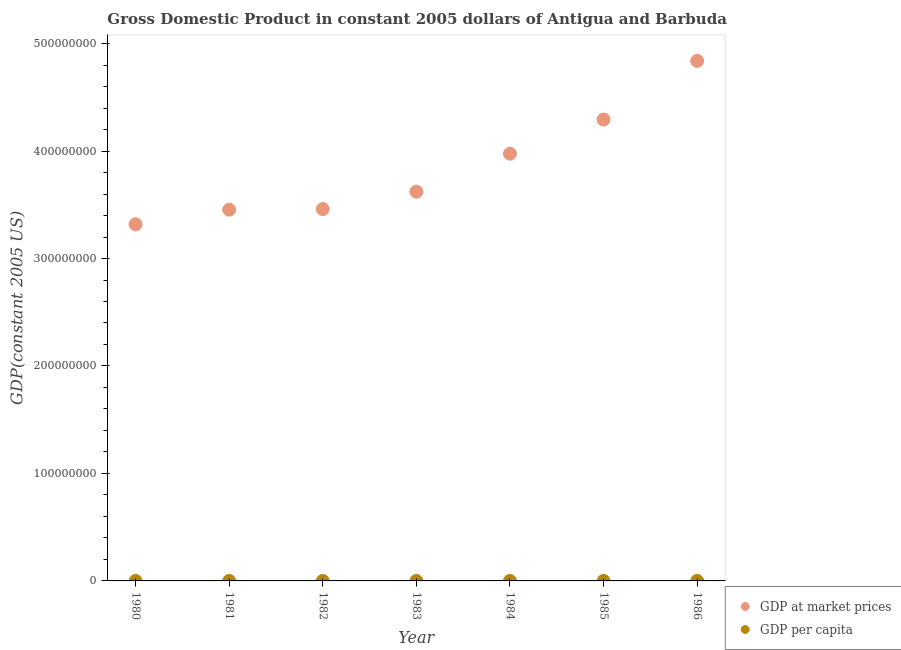How many different coloured dotlines are there?
Provide a short and direct response. 2. Is the number of dotlines equal to the number of legend labels?
Offer a very short reply. Yes. What is the gdp at market prices in 1985?
Offer a very short reply. 4.29e+08. Across all years, what is the maximum gdp at market prices?
Your answer should be compact. 4.84e+08. Across all years, what is the minimum gdp per capita?
Your answer should be compact. 4720.85. In which year was the gdp at market prices minimum?
Provide a short and direct response. 1980. What is the total gdp at market prices in the graph?
Keep it short and to the point. 2.70e+09. What is the difference between the gdp at market prices in 1980 and that in 1982?
Keep it short and to the point. -1.41e+07. What is the difference between the gdp at market prices in 1983 and the gdp per capita in 1986?
Your answer should be compact. 3.62e+08. What is the average gdp at market prices per year?
Offer a very short reply. 3.85e+08. In the year 1980, what is the difference between the gdp per capita and gdp at market prices?
Provide a succinct answer. -3.32e+08. In how many years, is the gdp per capita greater than 100000000 US$?
Offer a terse response. 0. What is the ratio of the gdp at market prices in 1985 to that in 1986?
Keep it short and to the point. 0.89. Is the gdp per capita in 1985 less than that in 1986?
Your answer should be compact. Yes. What is the difference between the highest and the second highest gdp at market prices?
Provide a short and direct response. 5.46e+07. What is the difference between the highest and the lowest gdp at market prices?
Your response must be concise. 1.52e+08. In how many years, is the gdp per capita greater than the average gdp per capita taken over all years?
Offer a very short reply. 3. Is the sum of the gdp per capita in 1982 and 1984 greater than the maximum gdp at market prices across all years?
Your answer should be compact. No. Is the gdp per capita strictly greater than the gdp at market prices over the years?
Provide a short and direct response. No. Is the gdp at market prices strictly less than the gdp per capita over the years?
Your answer should be very brief. No. How many years are there in the graph?
Provide a short and direct response. 7. What is the difference between two consecutive major ticks on the Y-axis?
Your answer should be very brief. 1.00e+08. Does the graph contain grids?
Make the answer very short. No. Where does the legend appear in the graph?
Offer a very short reply. Bottom right. What is the title of the graph?
Offer a terse response. Gross Domestic Product in constant 2005 dollars of Antigua and Barbuda. Does "Urban agglomerations" appear as one of the legend labels in the graph?
Your answer should be very brief. No. What is the label or title of the X-axis?
Make the answer very short. Year. What is the label or title of the Y-axis?
Keep it short and to the point. GDP(constant 2005 US). What is the GDP(constant 2005 US) of GDP at market prices in 1980?
Make the answer very short. 3.32e+08. What is the GDP(constant 2005 US) of GDP per capita in 1980?
Your response must be concise. 4720.85. What is the GDP(constant 2005 US) of GDP at market prices in 1981?
Give a very brief answer. 3.45e+08. What is the GDP(constant 2005 US) of GDP per capita in 1981?
Offer a terse response. 4952.46. What is the GDP(constant 2005 US) of GDP at market prices in 1982?
Your answer should be very brief. 3.46e+08. What is the GDP(constant 2005 US) of GDP per capita in 1982?
Give a very brief answer. 5018.3. What is the GDP(constant 2005 US) of GDP at market prices in 1983?
Ensure brevity in your answer.  3.62e+08. What is the GDP(constant 2005 US) in GDP per capita in 1983?
Keep it short and to the point. 5329.76. What is the GDP(constant 2005 US) in GDP at market prices in 1984?
Provide a short and direct response. 3.98e+08. What is the GDP(constant 2005 US) in GDP per capita in 1984?
Your answer should be very brief. 5945.4. What is the GDP(constant 2005 US) in GDP at market prices in 1985?
Your response must be concise. 4.29e+08. What is the GDP(constant 2005 US) of GDP per capita in 1985?
Provide a succinct answer. 6529.73. What is the GDP(constant 2005 US) in GDP at market prices in 1986?
Keep it short and to the point. 4.84e+08. What is the GDP(constant 2005 US) in GDP per capita in 1986?
Give a very brief answer. 7490.04. Across all years, what is the maximum GDP(constant 2005 US) in GDP at market prices?
Give a very brief answer. 4.84e+08. Across all years, what is the maximum GDP(constant 2005 US) in GDP per capita?
Provide a short and direct response. 7490.04. Across all years, what is the minimum GDP(constant 2005 US) in GDP at market prices?
Make the answer very short. 3.32e+08. Across all years, what is the minimum GDP(constant 2005 US) in GDP per capita?
Ensure brevity in your answer.  4720.85. What is the total GDP(constant 2005 US) in GDP at market prices in the graph?
Your answer should be compact. 2.70e+09. What is the total GDP(constant 2005 US) in GDP per capita in the graph?
Ensure brevity in your answer.  4.00e+04. What is the difference between the GDP(constant 2005 US) in GDP at market prices in 1980 and that in 1981?
Offer a terse response. -1.36e+07. What is the difference between the GDP(constant 2005 US) in GDP per capita in 1980 and that in 1981?
Your answer should be very brief. -231.6. What is the difference between the GDP(constant 2005 US) in GDP at market prices in 1980 and that in 1982?
Offer a very short reply. -1.41e+07. What is the difference between the GDP(constant 2005 US) of GDP per capita in 1980 and that in 1982?
Make the answer very short. -297.45. What is the difference between the GDP(constant 2005 US) in GDP at market prices in 1980 and that in 1983?
Ensure brevity in your answer.  -3.03e+07. What is the difference between the GDP(constant 2005 US) of GDP per capita in 1980 and that in 1983?
Your response must be concise. -608.9. What is the difference between the GDP(constant 2005 US) in GDP at market prices in 1980 and that in 1984?
Your response must be concise. -6.56e+07. What is the difference between the GDP(constant 2005 US) in GDP per capita in 1980 and that in 1984?
Make the answer very short. -1224.54. What is the difference between the GDP(constant 2005 US) in GDP at market prices in 1980 and that in 1985?
Give a very brief answer. -9.74e+07. What is the difference between the GDP(constant 2005 US) in GDP per capita in 1980 and that in 1985?
Provide a succinct answer. -1808.88. What is the difference between the GDP(constant 2005 US) in GDP at market prices in 1980 and that in 1986?
Offer a very short reply. -1.52e+08. What is the difference between the GDP(constant 2005 US) in GDP per capita in 1980 and that in 1986?
Offer a very short reply. -2769.19. What is the difference between the GDP(constant 2005 US) in GDP at market prices in 1981 and that in 1982?
Give a very brief answer. -5.78e+05. What is the difference between the GDP(constant 2005 US) of GDP per capita in 1981 and that in 1982?
Provide a short and direct response. -65.84. What is the difference between the GDP(constant 2005 US) of GDP at market prices in 1981 and that in 1983?
Give a very brief answer. -1.68e+07. What is the difference between the GDP(constant 2005 US) of GDP per capita in 1981 and that in 1983?
Your answer should be compact. -377.3. What is the difference between the GDP(constant 2005 US) of GDP at market prices in 1981 and that in 1984?
Give a very brief answer. -5.21e+07. What is the difference between the GDP(constant 2005 US) in GDP per capita in 1981 and that in 1984?
Give a very brief answer. -992.94. What is the difference between the GDP(constant 2005 US) in GDP at market prices in 1981 and that in 1985?
Provide a succinct answer. -8.39e+07. What is the difference between the GDP(constant 2005 US) in GDP per capita in 1981 and that in 1985?
Provide a succinct answer. -1577.28. What is the difference between the GDP(constant 2005 US) in GDP at market prices in 1981 and that in 1986?
Offer a very short reply. -1.38e+08. What is the difference between the GDP(constant 2005 US) of GDP per capita in 1981 and that in 1986?
Ensure brevity in your answer.  -2537.58. What is the difference between the GDP(constant 2005 US) in GDP at market prices in 1982 and that in 1983?
Make the answer very short. -1.62e+07. What is the difference between the GDP(constant 2005 US) in GDP per capita in 1982 and that in 1983?
Offer a very short reply. -311.46. What is the difference between the GDP(constant 2005 US) of GDP at market prices in 1982 and that in 1984?
Offer a terse response. -5.15e+07. What is the difference between the GDP(constant 2005 US) in GDP per capita in 1982 and that in 1984?
Give a very brief answer. -927.1. What is the difference between the GDP(constant 2005 US) in GDP at market prices in 1982 and that in 1985?
Offer a very short reply. -8.33e+07. What is the difference between the GDP(constant 2005 US) in GDP per capita in 1982 and that in 1985?
Provide a succinct answer. -1511.43. What is the difference between the GDP(constant 2005 US) in GDP at market prices in 1982 and that in 1986?
Keep it short and to the point. -1.38e+08. What is the difference between the GDP(constant 2005 US) in GDP per capita in 1982 and that in 1986?
Your answer should be compact. -2471.74. What is the difference between the GDP(constant 2005 US) of GDP at market prices in 1983 and that in 1984?
Your answer should be very brief. -3.53e+07. What is the difference between the GDP(constant 2005 US) in GDP per capita in 1983 and that in 1984?
Give a very brief answer. -615.64. What is the difference between the GDP(constant 2005 US) of GDP at market prices in 1983 and that in 1985?
Ensure brevity in your answer.  -6.71e+07. What is the difference between the GDP(constant 2005 US) of GDP per capita in 1983 and that in 1985?
Make the answer very short. -1199.98. What is the difference between the GDP(constant 2005 US) in GDP at market prices in 1983 and that in 1986?
Offer a very short reply. -1.22e+08. What is the difference between the GDP(constant 2005 US) in GDP per capita in 1983 and that in 1986?
Offer a terse response. -2160.28. What is the difference between the GDP(constant 2005 US) of GDP at market prices in 1984 and that in 1985?
Offer a terse response. -3.18e+07. What is the difference between the GDP(constant 2005 US) in GDP per capita in 1984 and that in 1985?
Offer a very short reply. -584.34. What is the difference between the GDP(constant 2005 US) of GDP at market prices in 1984 and that in 1986?
Provide a short and direct response. -8.64e+07. What is the difference between the GDP(constant 2005 US) of GDP per capita in 1984 and that in 1986?
Your answer should be compact. -1544.64. What is the difference between the GDP(constant 2005 US) of GDP at market prices in 1985 and that in 1986?
Offer a very short reply. -5.46e+07. What is the difference between the GDP(constant 2005 US) of GDP per capita in 1985 and that in 1986?
Make the answer very short. -960.31. What is the difference between the GDP(constant 2005 US) in GDP at market prices in 1980 and the GDP(constant 2005 US) in GDP per capita in 1981?
Your answer should be very brief. 3.32e+08. What is the difference between the GDP(constant 2005 US) of GDP at market prices in 1980 and the GDP(constant 2005 US) of GDP per capita in 1982?
Ensure brevity in your answer.  3.32e+08. What is the difference between the GDP(constant 2005 US) in GDP at market prices in 1980 and the GDP(constant 2005 US) in GDP per capita in 1983?
Your answer should be very brief. 3.32e+08. What is the difference between the GDP(constant 2005 US) in GDP at market prices in 1980 and the GDP(constant 2005 US) in GDP per capita in 1984?
Make the answer very short. 3.32e+08. What is the difference between the GDP(constant 2005 US) of GDP at market prices in 1980 and the GDP(constant 2005 US) of GDP per capita in 1985?
Offer a very short reply. 3.32e+08. What is the difference between the GDP(constant 2005 US) of GDP at market prices in 1980 and the GDP(constant 2005 US) of GDP per capita in 1986?
Your response must be concise. 3.32e+08. What is the difference between the GDP(constant 2005 US) of GDP at market prices in 1981 and the GDP(constant 2005 US) of GDP per capita in 1982?
Provide a short and direct response. 3.45e+08. What is the difference between the GDP(constant 2005 US) in GDP at market prices in 1981 and the GDP(constant 2005 US) in GDP per capita in 1983?
Your answer should be very brief. 3.45e+08. What is the difference between the GDP(constant 2005 US) in GDP at market prices in 1981 and the GDP(constant 2005 US) in GDP per capita in 1984?
Offer a very short reply. 3.45e+08. What is the difference between the GDP(constant 2005 US) in GDP at market prices in 1981 and the GDP(constant 2005 US) in GDP per capita in 1985?
Make the answer very short. 3.45e+08. What is the difference between the GDP(constant 2005 US) in GDP at market prices in 1981 and the GDP(constant 2005 US) in GDP per capita in 1986?
Offer a very short reply. 3.45e+08. What is the difference between the GDP(constant 2005 US) of GDP at market prices in 1982 and the GDP(constant 2005 US) of GDP per capita in 1983?
Provide a succinct answer. 3.46e+08. What is the difference between the GDP(constant 2005 US) of GDP at market prices in 1982 and the GDP(constant 2005 US) of GDP per capita in 1984?
Keep it short and to the point. 3.46e+08. What is the difference between the GDP(constant 2005 US) of GDP at market prices in 1982 and the GDP(constant 2005 US) of GDP per capita in 1985?
Offer a terse response. 3.46e+08. What is the difference between the GDP(constant 2005 US) of GDP at market prices in 1982 and the GDP(constant 2005 US) of GDP per capita in 1986?
Provide a short and direct response. 3.46e+08. What is the difference between the GDP(constant 2005 US) of GDP at market prices in 1983 and the GDP(constant 2005 US) of GDP per capita in 1984?
Your response must be concise. 3.62e+08. What is the difference between the GDP(constant 2005 US) in GDP at market prices in 1983 and the GDP(constant 2005 US) in GDP per capita in 1985?
Your answer should be compact. 3.62e+08. What is the difference between the GDP(constant 2005 US) in GDP at market prices in 1983 and the GDP(constant 2005 US) in GDP per capita in 1986?
Your response must be concise. 3.62e+08. What is the difference between the GDP(constant 2005 US) in GDP at market prices in 1984 and the GDP(constant 2005 US) in GDP per capita in 1985?
Your answer should be compact. 3.98e+08. What is the difference between the GDP(constant 2005 US) of GDP at market prices in 1984 and the GDP(constant 2005 US) of GDP per capita in 1986?
Offer a terse response. 3.98e+08. What is the difference between the GDP(constant 2005 US) in GDP at market prices in 1985 and the GDP(constant 2005 US) in GDP per capita in 1986?
Offer a terse response. 4.29e+08. What is the average GDP(constant 2005 US) in GDP at market prices per year?
Your response must be concise. 3.85e+08. What is the average GDP(constant 2005 US) of GDP per capita per year?
Your answer should be very brief. 5712.36. In the year 1980, what is the difference between the GDP(constant 2005 US) of GDP at market prices and GDP(constant 2005 US) of GDP per capita?
Offer a very short reply. 3.32e+08. In the year 1981, what is the difference between the GDP(constant 2005 US) of GDP at market prices and GDP(constant 2005 US) of GDP per capita?
Offer a terse response. 3.45e+08. In the year 1982, what is the difference between the GDP(constant 2005 US) of GDP at market prices and GDP(constant 2005 US) of GDP per capita?
Offer a terse response. 3.46e+08. In the year 1983, what is the difference between the GDP(constant 2005 US) in GDP at market prices and GDP(constant 2005 US) in GDP per capita?
Offer a terse response. 3.62e+08. In the year 1984, what is the difference between the GDP(constant 2005 US) of GDP at market prices and GDP(constant 2005 US) of GDP per capita?
Make the answer very short. 3.98e+08. In the year 1985, what is the difference between the GDP(constant 2005 US) in GDP at market prices and GDP(constant 2005 US) in GDP per capita?
Provide a succinct answer. 4.29e+08. In the year 1986, what is the difference between the GDP(constant 2005 US) of GDP at market prices and GDP(constant 2005 US) of GDP per capita?
Ensure brevity in your answer.  4.84e+08. What is the ratio of the GDP(constant 2005 US) in GDP at market prices in 1980 to that in 1981?
Your answer should be very brief. 0.96. What is the ratio of the GDP(constant 2005 US) in GDP per capita in 1980 to that in 1981?
Your answer should be compact. 0.95. What is the ratio of the GDP(constant 2005 US) of GDP at market prices in 1980 to that in 1982?
Your answer should be compact. 0.96. What is the ratio of the GDP(constant 2005 US) in GDP per capita in 1980 to that in 1982?
Keep it short and to the point. 0.94. What is the ratio of the GDP(constant 2005 US) of GDP at market prices in 1980 to that in 1983?
Keep it short and to the point. 0.92. What is the ratio of the GDP(constant 2005 US) in GDP per capita in 1980 to that in 1983?
Offer a very short reply. 0.89. What is the ratio of the GDP(constant 2005 US) of GDP at market prices in 1980 to that in 1984?
Your answer should be very brief. 0.83. What is the ratio of the GDP(constant 2005 US) of GDP per capita in 1980 to that in 1984?
Your response must be concise. 0.79. What is the ratio of the GDP(constant 2005 US) in GDP at market prices in 1980 to that in 1985?
Keep it short and to the point. 0.77. What is the ratio of the GDP(constant 2005 US) of GDP per capita in 1980 to that in 1985?
Offer a very short reply. 0.72. What is the ratio of the GDP(constant 2005 US) of GDP at market prices in 1980 to that in 1986?
Provide a succinct answer. 0.69. What is the ratio of the GDP(constant 2005 US) in GDP per capita in 1980 to that in 1986?
Offer a very short reply. 0.63. What is the ratio of the GDP(constant 2005 US) in GDP at market prices in 1981 to that in 1982?
Provide a short and direct response. 1. What is the ratio of the GDP(constant 2005 US) of GDP per capita in 1981 to that in 1982?
Your response must be concise. 0.99. What is the ratio of the GDP(constant 2005 US) in GDP at market prices in 1981 to that in 1983?
Your answer should be very brief. 0.95. What is the ratio of the GDP(constant 2005 US) in GDP per capita in 1981 to that in 1983?
Ensure brevity in your answer.  0.93. What is the ratio of the GDP(constant 2005 US) in GDP at market prices in 1981 to that in 1984?
Make the answer very short. 0.87. What is the ratio of the GDP(constant 2005 US) of GDP per capita in 1981 to that in 1984?
Provide a short and direct response. 0.83. What is the ratio of the GDP(constant 2005 US) of GDP at market prices in 1981 to that in 1985?
Your answer should be very brief. 0.8. What is the ratio of the GDP(constant 2005 US) of GDP per capita in 1981 to that in 1985?
Offer a terse response. 0.76. What is the ratio of the GDP(constant 2005 US) in GDP at market prices in 1981 to that in 1986?
Keep it short and to the point. 0.71. What is the ratio of the GDP(constant 2005 US) of GDP per capita in 1981 to that in 1986?
Your response must be concise. 0.66. What is the ratio of the GDP(constant 2005 US) of GDP at market prices in 1982 to that in 1983?
Offer a terse response. 0.96. What is the ratio of the GDP(constant 2005 US) in GDP per capita in 1982 to that in 1983?
Provide a succinct answer. 0.94. What is the ratio of the GDP(constant 2005 US) in GDP at market prices in 1982 to that in 1984?
Give a very brief answer. 0.87. What is the ratio of the GDP(constant 2005 US) of GDP per capita in 1982 to that in 1984?
Your answer should be very brief. 0.84. What is the ratio of the GDP(constant 2005 US) of GDP at market prices in 1982 to that in 1985?
Ensure brevity in your answer.  0.81. What is the ratio of the GDP(constant 2005 US) in GDP per capita in 1982 to that in 1985?
Offer a terse response. 0.77. What is the ratio of the GDP(constant 2005 US) in GDP at market prices in 1982 to that in 1986?
Ensure brevity in your answer.  0.72. What is the ratio of the GDP(constant 2005 US) in GDP per capita in 1982 to that in 1986?
Provide a short and direct response. 0.67. What is the ratio of the GDP(constant 2005 US) in GDP at market prices in 1983 to that in 1984?
Your answer should be very brief. 0.91. What is the ratio of the GDP(constant 2005 US) of GDP per capita in 1983 to that in 1984?
Make the answer very short. 0.9. What is the ratio of the GDP(constant 2005 US) of GDP at market prices in 1983 to that in 1985?
Make the answer very short. 0.84. What is the ratio of the GDP(constant 2005 US) in GDP per capita in 1983 to that in 1985?
Your answer should be very brief. 0.82. What is the ratio of the GDP(constant 2005 US) of GDP at market prices in 1983 to that in 1986?
Your answer should be compact. 0.75. What is the ratio of the GDP(constant 2005 US) of GDP per capita in 1983 to that in 1986?
Your response must be concise. 0.71. What is the ratio of the GDP(constant 2005 US) of GDP at market prices in 1984 to that in 1985?
Ensure brevity in your answer.  0.93. What is the ratio of the GDP(constant 2005 US) of GDP per capita in 1984 to that in 1985?
Offer a very short reply. 0.91. What is the ratio of the GDP(constant 2005 US) of GDP at market prices in 1984 to that in 1986?
Offer a very short reply. 0.82. What is the ratio of the GDP(constant 2005 US) in GDP per capita in 1984 to that in 1986?
Ensure brevity in your answer.  0.79. What is the ratio of the GDP(constant 2005 US) in GDP at market prices in 1985 to that in 1986?
Give a very brief answer. 0.89. What is the ratio of the GDP(constant 2005 US) of GDP per capita in 1985 to that in 1986?
Offer a very short reply. 0.87. What is the difference between the highest and the second highest GDP(constant 2005 US) in GDP at market prices?
Offer a very short reply. 5.46e+07. What is the difference between the highest and the second highest GDP(constant 2005 US) of GDP per capita?
Give a very brief answer. 960.31. What is the difference between the highest and the lowest GDP(constant 2005 US) of GDP at market prices?
Offer a terse response. 1.52e+08. What is the difference between the highest and the lowest GDP(constant 2005 US) of GDP per capita?
Your response must be concise. 2769.19. 